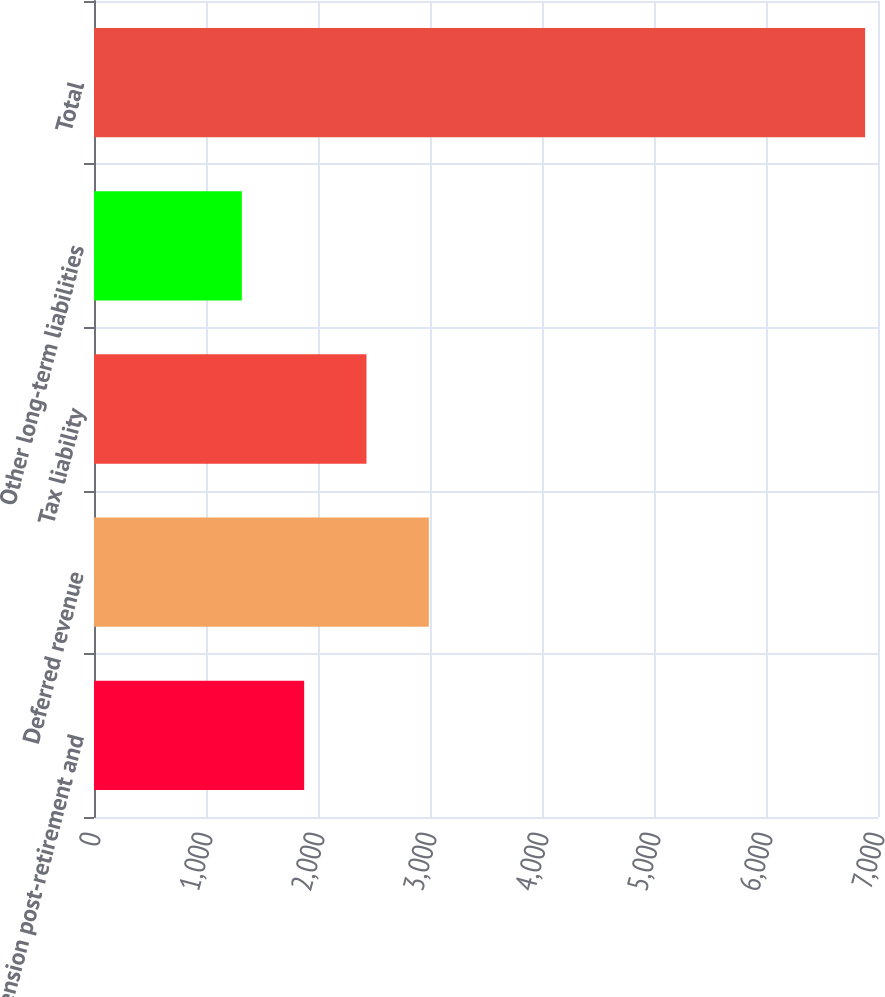Convert chart to OTSL. <chart><loc_0><loc_0><loc_500><loc_500><bar_chart><fcel>Pension post-retirement and<fcel>Deferred revenue<fcel>Tax liability<fcel>Other long-term liabilities<fcel>Total<nl><fcel>1876.5<fcel>2989.5<fcel>2433<fcel>1320<fcel>6885<nl></chart> 